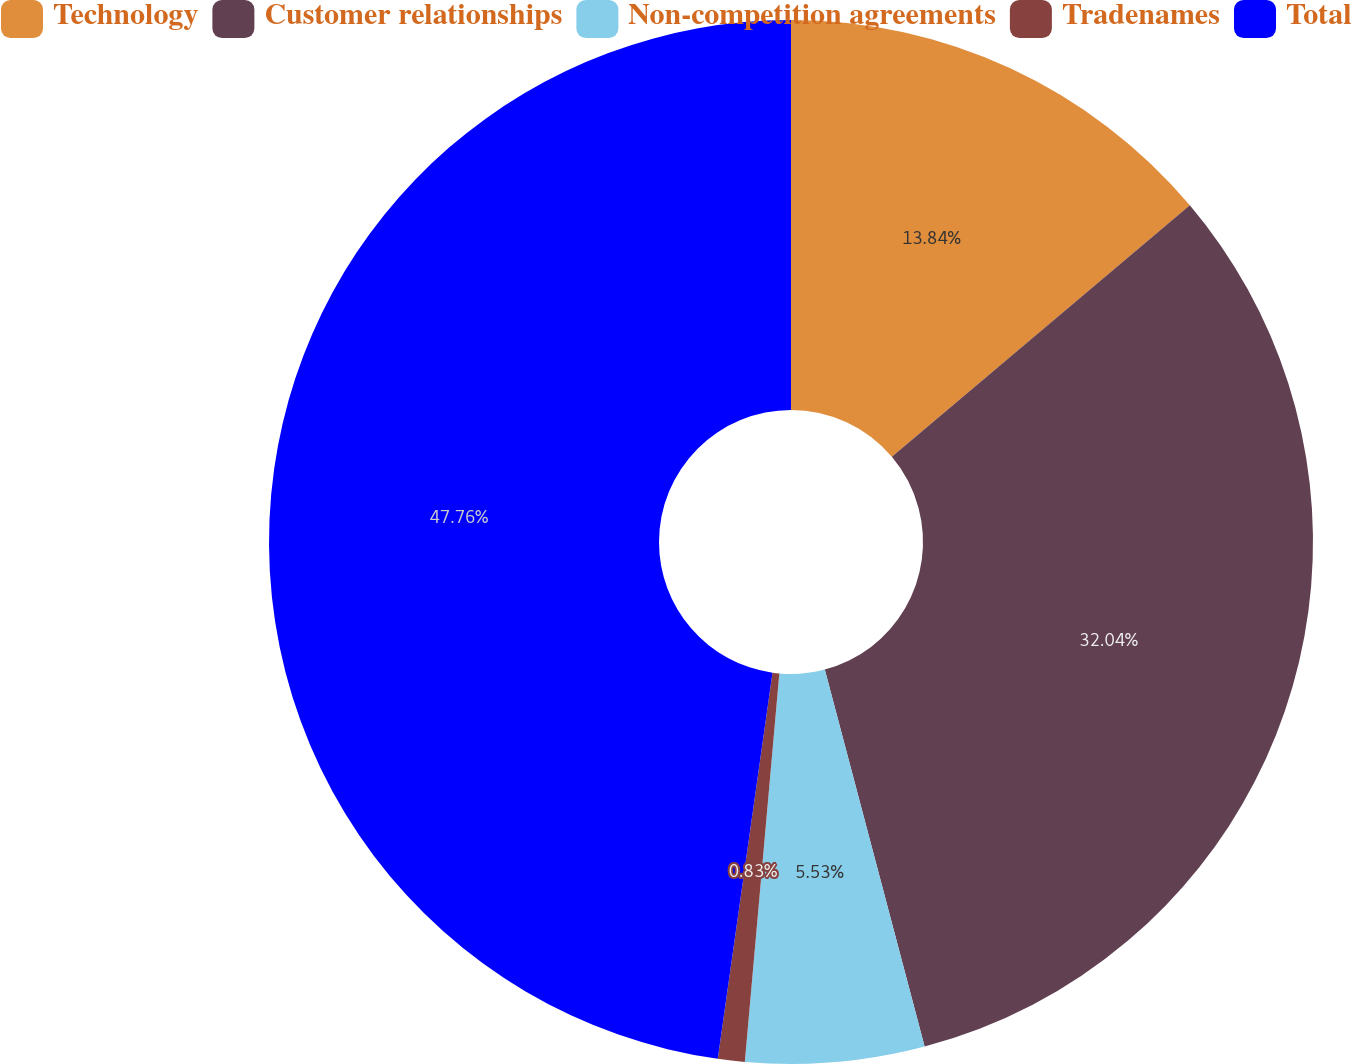Convert chart. <chart><loc_0><loc_0><loc_500><loc_500><pie_chart><fcel>Technology<fcel>Customer relationships<fcel>Non-competition agreements<fcel>Tradenames<fcel>Total<nl><fcel>13.84%<fcel>32.04%<fcel>5.53%<fcel>0.83%<fcel>47.76%<nl></chart> 